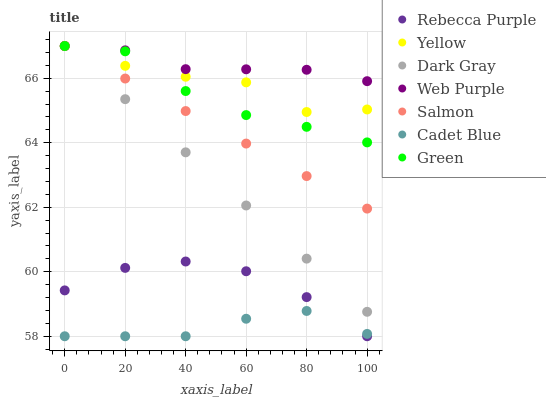Does Cadet Blue have the minimum area under the curve?
Answer yes or no. Yes. Does Web Purple have the maximum area under the curve?
Answer yes or no. Yes. Does Salmon have the minimum area under the curve?
Answer yes or no. No. Does Salmon have the maximum area under the curve?
Answer yes or no. No. Is Dark Gray the smoothest?
Answer yes or no. Yes. Is Yellow the roughest?
Answer yes or no. Yes. Is Salmon the smoothest?
Answer yes or no. No. Is Salmon the roughest?
Answer yes or no. No. Does Cadet Blue have the lowest value?
Answer yes or no. Yes. Does Salmon have the lowest value?
Answer yes or no. No. Does Green have the highest value?
Answer yes or no. Yes. Does Rebecca Purple have the highest value?
Answer yes or no. No. Is Rebecca Purple less than Web Purple?
Answer yes or no. Yes. Is Dark Gray greater than Rebecca Purple?
Answer yes or no. Yes. Does Salmon intersect Green?
Answer yes or no. Yes. Is Salmon less than Green?
Answer yes or no. No. Is Salmon greater than Green?
Answer yes or no. No. Does Rebecca Purple intersect Web Purple?
Answer yes or no. No. 